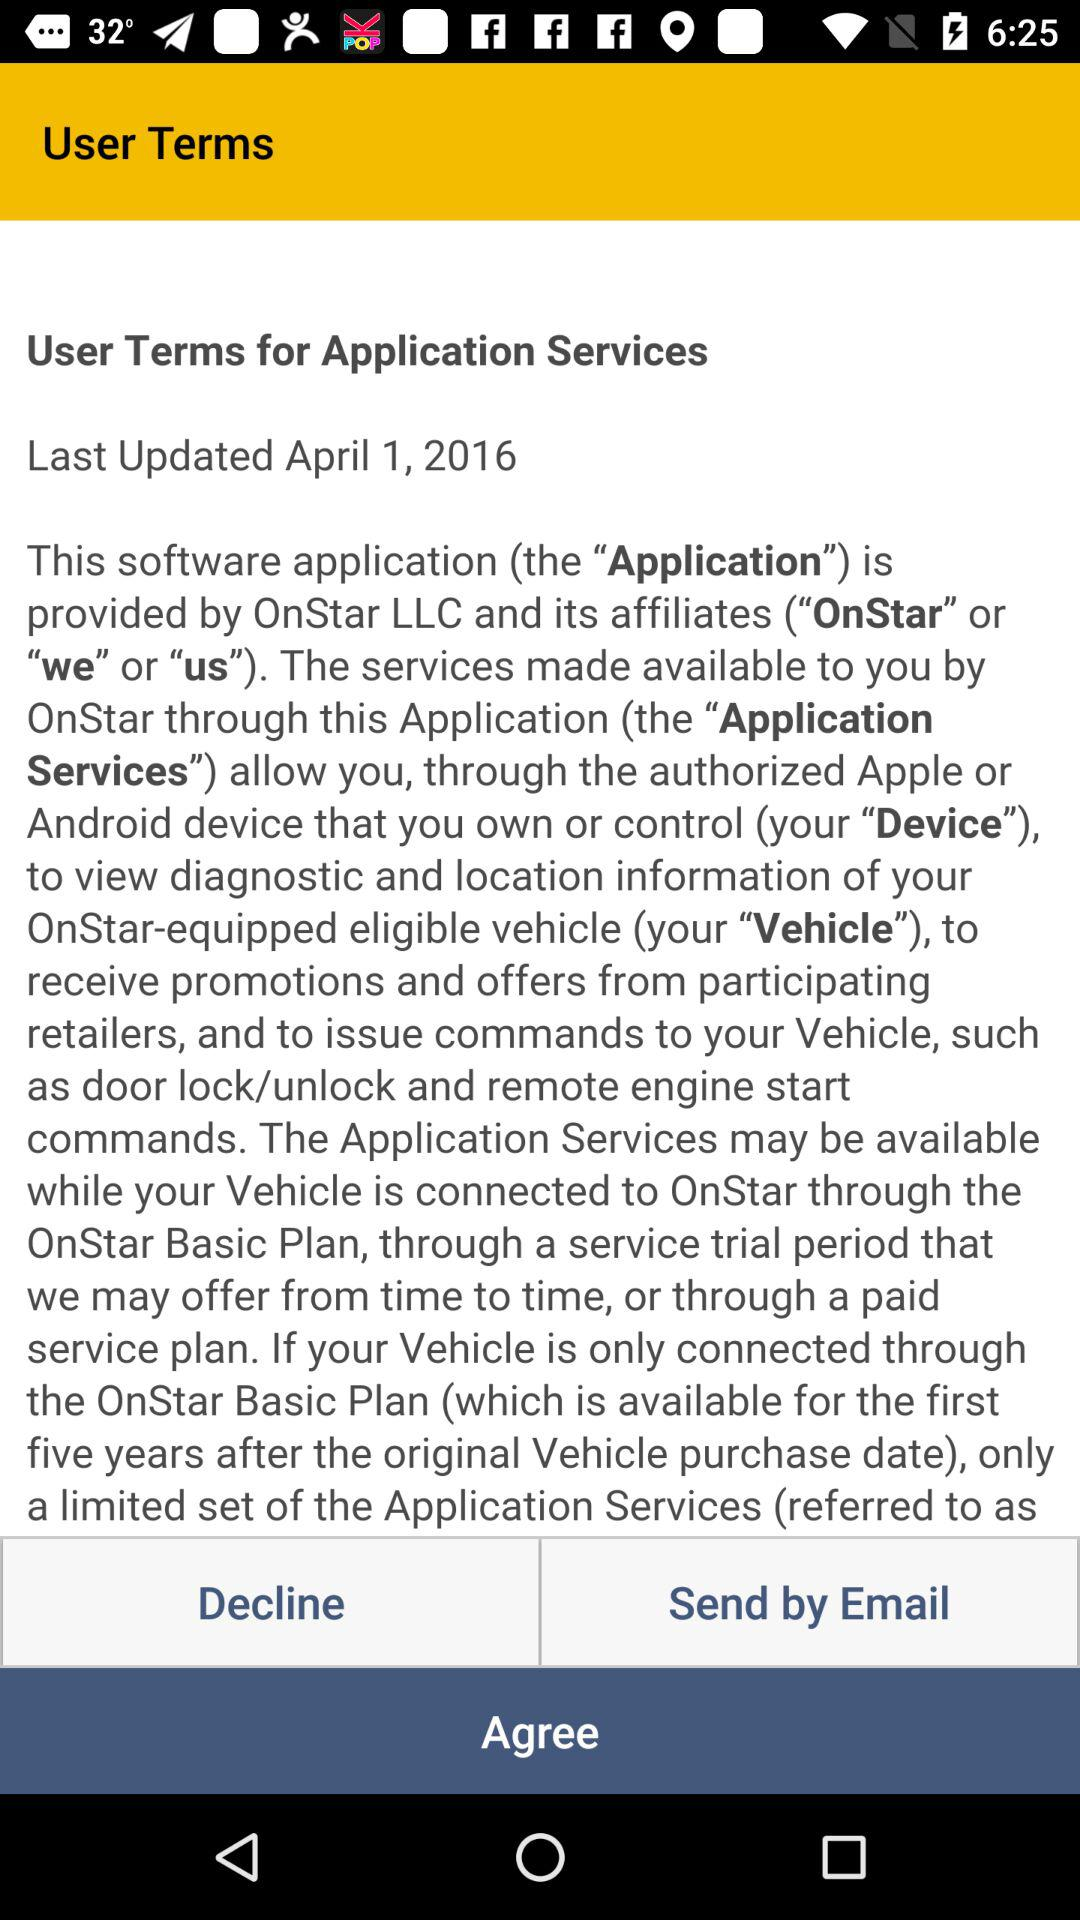What is the user's email?
When the provided information is insufficient, respond with <no answer>. <no answer> 